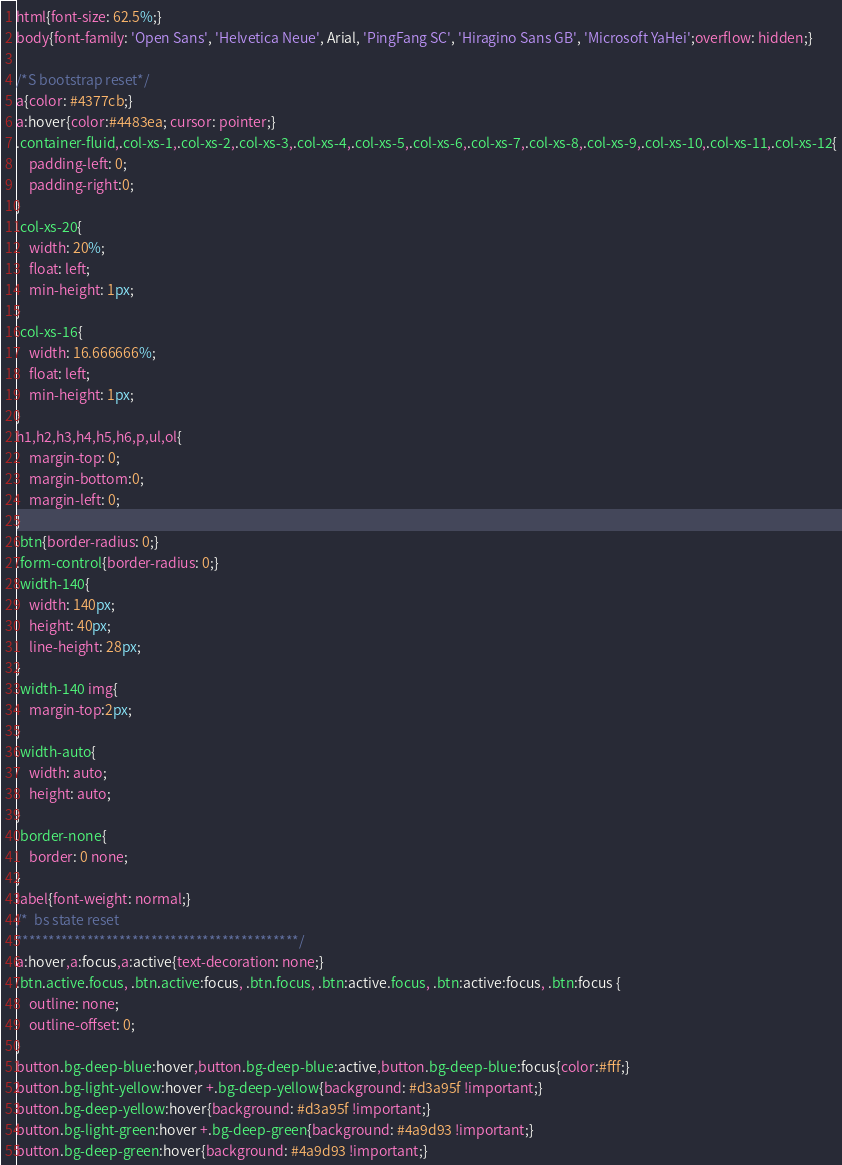Convert code to text. <code><loc_0><loc_0><loc_500><loc_500><_CSS_>html{font-size: 62.5%;}
body{font-family: 'Open Sans', 'Helvetica Neue', Arial, 'PingFang SC', 'Hiragino Sans GB', 'Microsoft YaHei';overflow: hidden;}

/*S bootstrap reset*/
a{color: #4377cb;}
a:hover{color:#4483ea; cursor: pointer;}
.container-fluid,.col-xs-1,.col-xs-2,.col-xs-3,.col-xs-4,.col-xs-5,.col-xs-6,.col-xs-7,.col-xs-8,.col-xs-9,.col-xs-10,.col-xs-11,.col-xs-12{
    padding-left: 0;
    padding-right:0;
}
.col-xs-20{
    width: 20%;
    float: left;
    min-height: 1px;
}
.col-xs-16{
    width: 16.666666%;
    float: left;
    min-height: 1px;
}
h1,h2,h3,h4,h5,h6,p,ul,ol{
    margin-top: 0;
    margin-bottom:0;
    margin-left: 0;
}
.btn{border-radius: 0;}
.form-control{border-radius: 0;}
.width-140{
    width: 140px;
    height: 40px;
    line-height: 28px;
}
.width-140 img{
    margin-top:2px;
}
.width-auto{
    width: auto;
    height: auto;
}
.border-none{
    border: 0 none;
}
label{font-weight: normal;}
/*  bs state reset
********************************************/
a:hover,a:focus,a:active{text-decoration: none;}
.btn.active.focus, .btn.active:focus, .btn.focus, .btn:active.focus, .btn:active:focus, .btn:focus {
    outline: none;
    outline-offset: 0;
}
button.bg-deep-blue:hover,button.bg-deep-blue:active,button.bg-deep-blue:focus{color:#fff;}
button.bg-light-yellow:hover +.bg-deep-yellow{background: #d3a95f !important;}
button.bg-deep-yellow:hover{background: #d3a95f !important;}
button.bg-light-green:hover +.bg-deep-green{background: #4a9d93 !important;}
button.bg-deep-green:hover{background: #4a9d93 !important;}</code> 